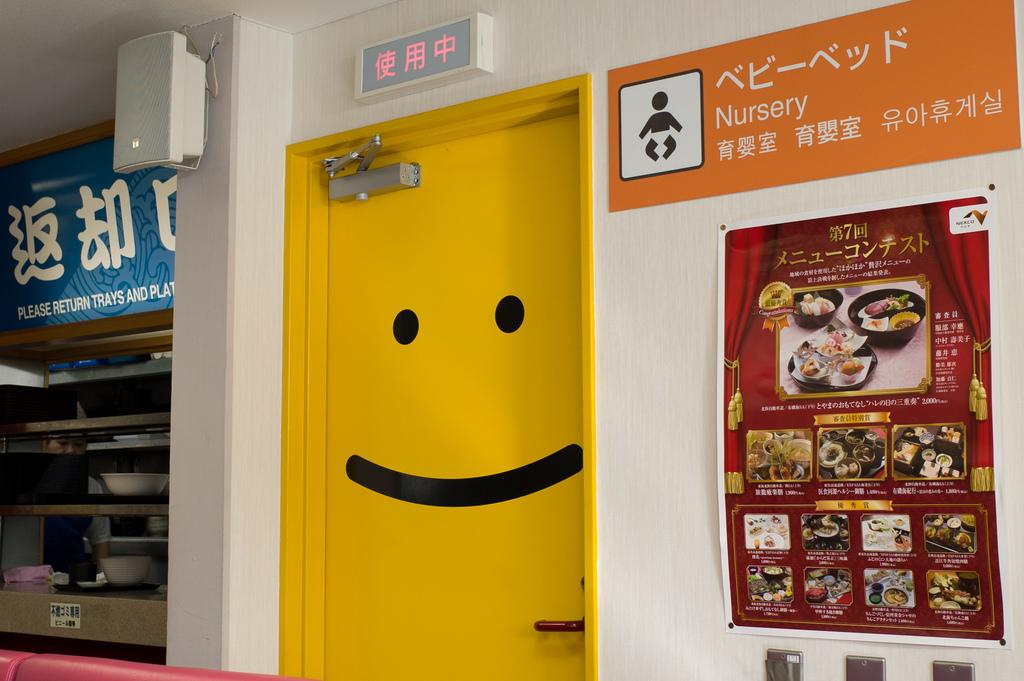<image>
Give a short and clear explanation of the subsequent image. A large yellow door with a black smiley face on it next to a Nursery sign. 